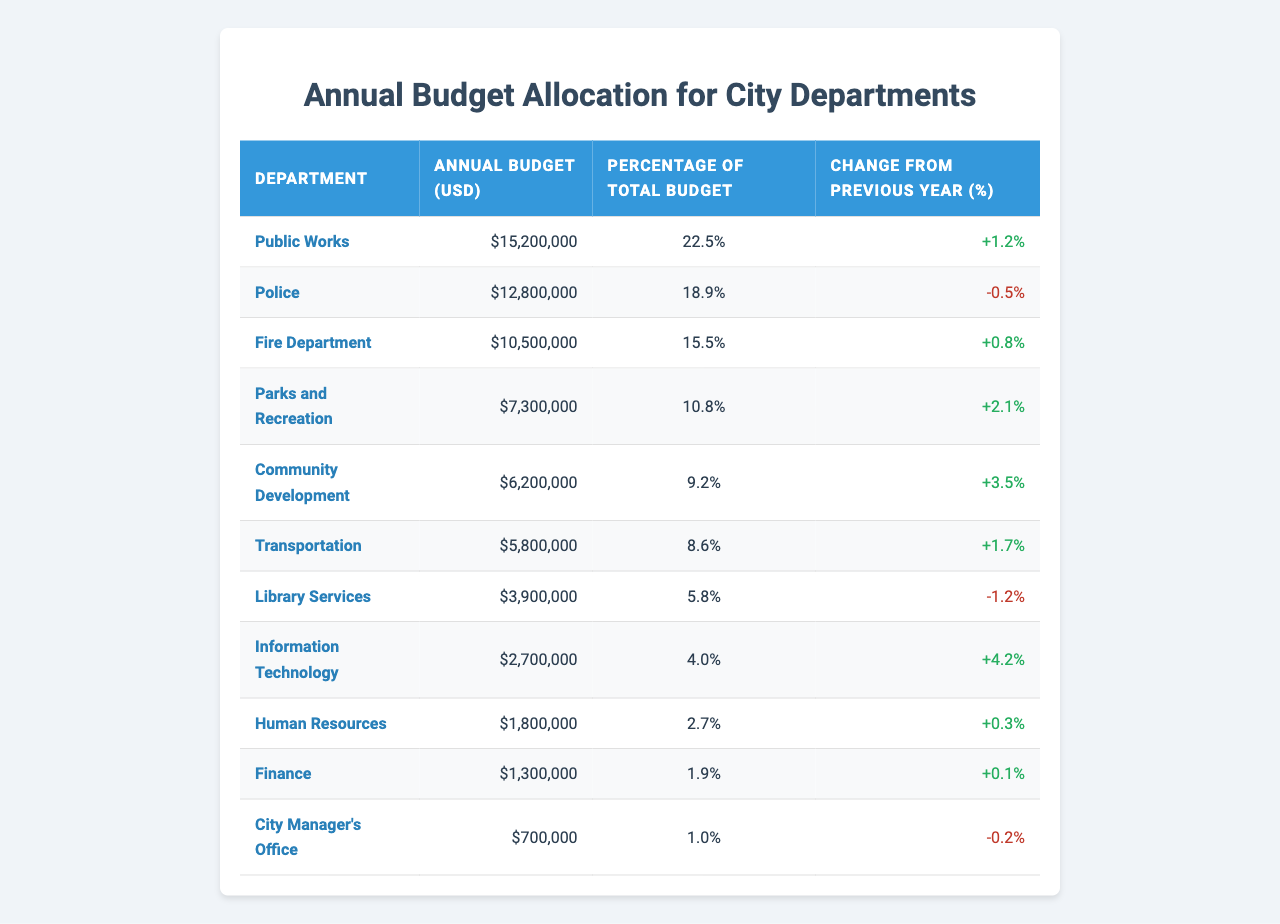What is the annual budget for the Police department? The table provides the specific annual budget for the Police department, which is listed as $12,800,000.
Answer: $12,800,000 Which department has the largest annual budget? By reviewing the "Annual Budget (USD)" column, the Public Works department has the largest annual budget at $15,200,000.
Answer: Public Works What is the percentage of the total budget allocated to the Fire Department? The "Percentage of Total Budget" for the Fire Department is clearly listed in the table as 15.5%.
Answer: 15.5% How much more budget does the Public Works department have compared to the Transportation department? The budget for Public Works is $15,200,000 and for Transportation is $5,800,000. Subtracting these amounts gives us $15,200,000 - $5,800,000 = $9,400,000.
Answer: $9,400,000 Is the budget for Library Services increasing compared to the previous year? The "Change from Previous Year (%)" for Library Services is -1.2%, indicating a decrease.
Answer: No What is the total budget allocated across all departments? To find the total budget, we sum all individual budgets: $15,200,000 + $12,800,000 + $10,500,000 + $7,300,000 + $6,200,000 + $5,800,000 + $3,900,000 + $2,700,000 + $1,800,000 + $1,300,000 + $700,000 = $67,500,000.
Answer: $67,500,000 Which department had the most significant percentage increase in budget compared to the previous year? By comparing the "Change from Previous Year (%)" values, Community Development has the highest increase at 3.5%.
Answer: Community Development What is the average budget allocated for the departments listed? The average budget is calculated by dividing the total budget ($67,500,000) by the number of departments (11), which results in $67,500,000 / 11 = $6,136,364 (rounded to the nearest dollar).
Answer: $6,136,364 Does Human Resources have a higher budget than the City Manager's Office? Comparing their respective budgets, Human Resources has $1,800,000 and the City Manager's Office has $700,000, thus Human Resources has a higher budget.
Answer: Yes What percentage of the total budget does the combined allocation for the Parks and Recreation and Community Development departments represent? Adding the budgets for these two departments gives $7,300,000 + $6,200,000 = $13,500,000. The percentage of the total budget is calculated as ($13,500,000 / $67,500,000) * 100 = 20%.
Answer: 20% If the Fire Department's budget were to increase by 10%, what would the new budget be? A 10% increase from the current budget of $10,500,000 would be 10% of $10,500,000, which is $1,050,000. Adding this to the current budget gives $10,500,000 + $1,050,000 = $11,550,000.
Answer: $11,550,000 